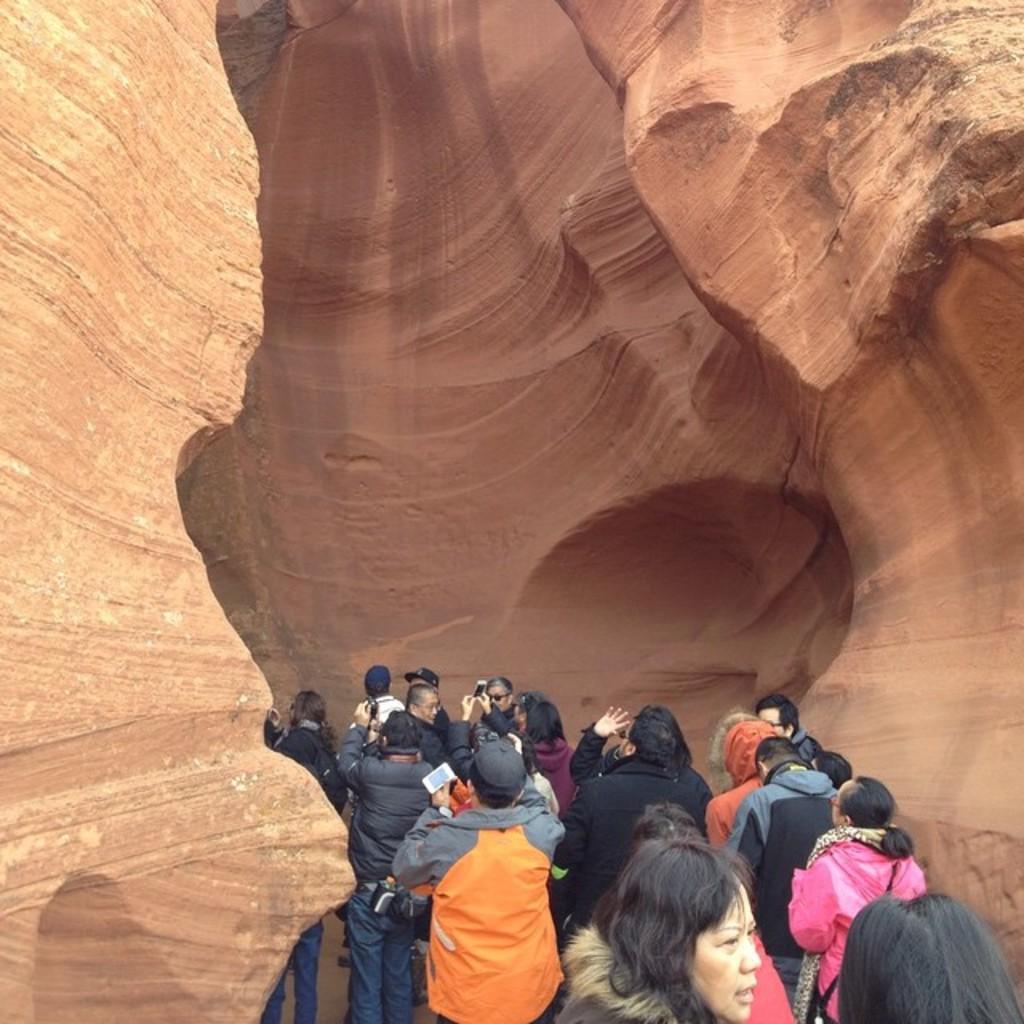Can you describe this image briefly? In this picture I can see group of people standing, and in the background there is a canyon. 